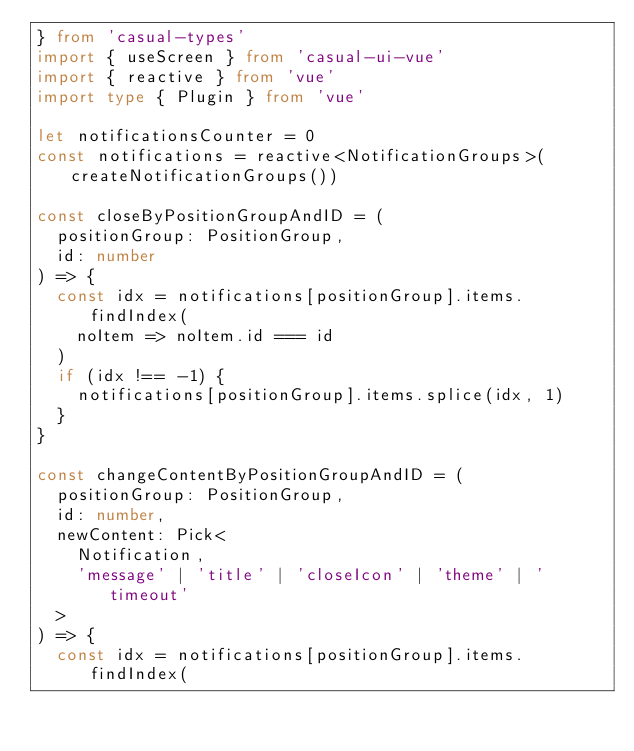Convert code to text. <code><loc_0><loc_0><loc_500><loc_500><_TypeScript_>} from 'casual-types'
import { useScreen } from 'casual-ui-vue'
import { reactive } from 'vue'
import type { Plugin } from 'vue'

let notificationsCounter = 0
const notifications = reactive<NotificationGroups>(createNotificationGroups())

const closeByPositionGroupAndID = (
  positionGroup: PositionGroup,
  id: number
) => {
  const idx = notifications[positionGroup].items.findIndex(
    noItem => noItem.id === id
  )
  if (idx !== -1) {
    notifications[positionGroup].items.splice(idx, 1)
  }
}

const changeContentByPositionGroupAndID = (
  positionGroup: PositionGroup,
  id: number,
  newContent: Pick<
    Notification,
    'message' | 'title' | 'closeIcon' | 'theme' | 'timeout'
  >
) => {
  const idx = notifications[positionGroup].items.findIndex(</code> 